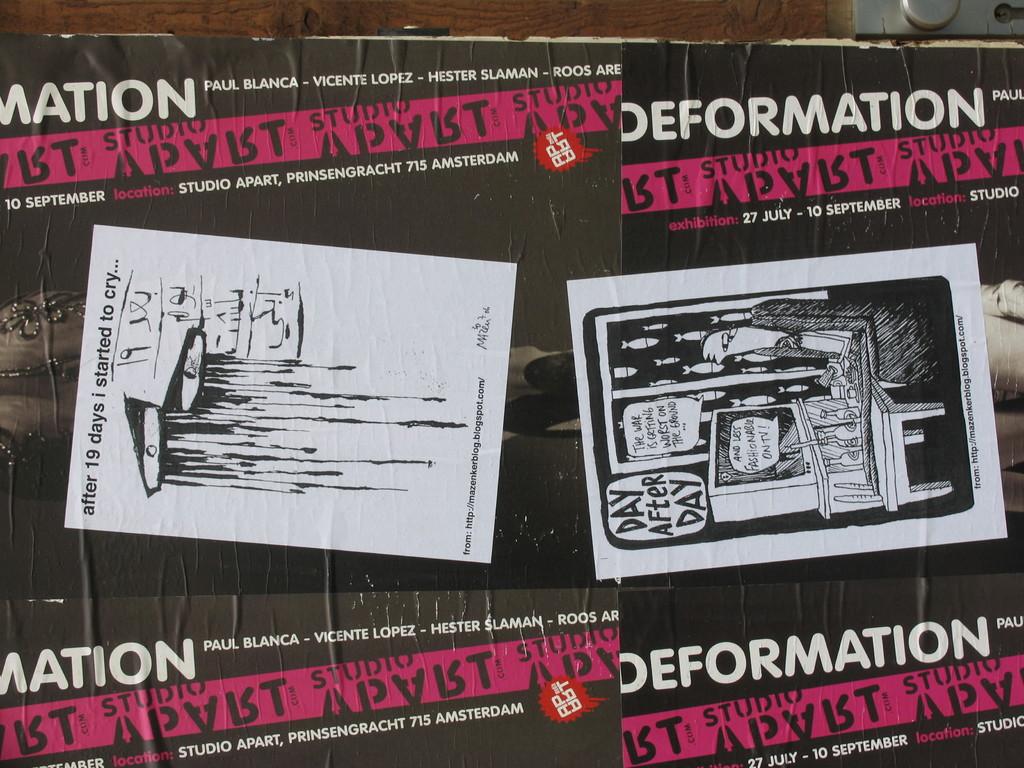What did they do after 19 days?
Your answer should be compact. Started to cry. What is paul's last name?
Your answer should be very brief. Blanca. 